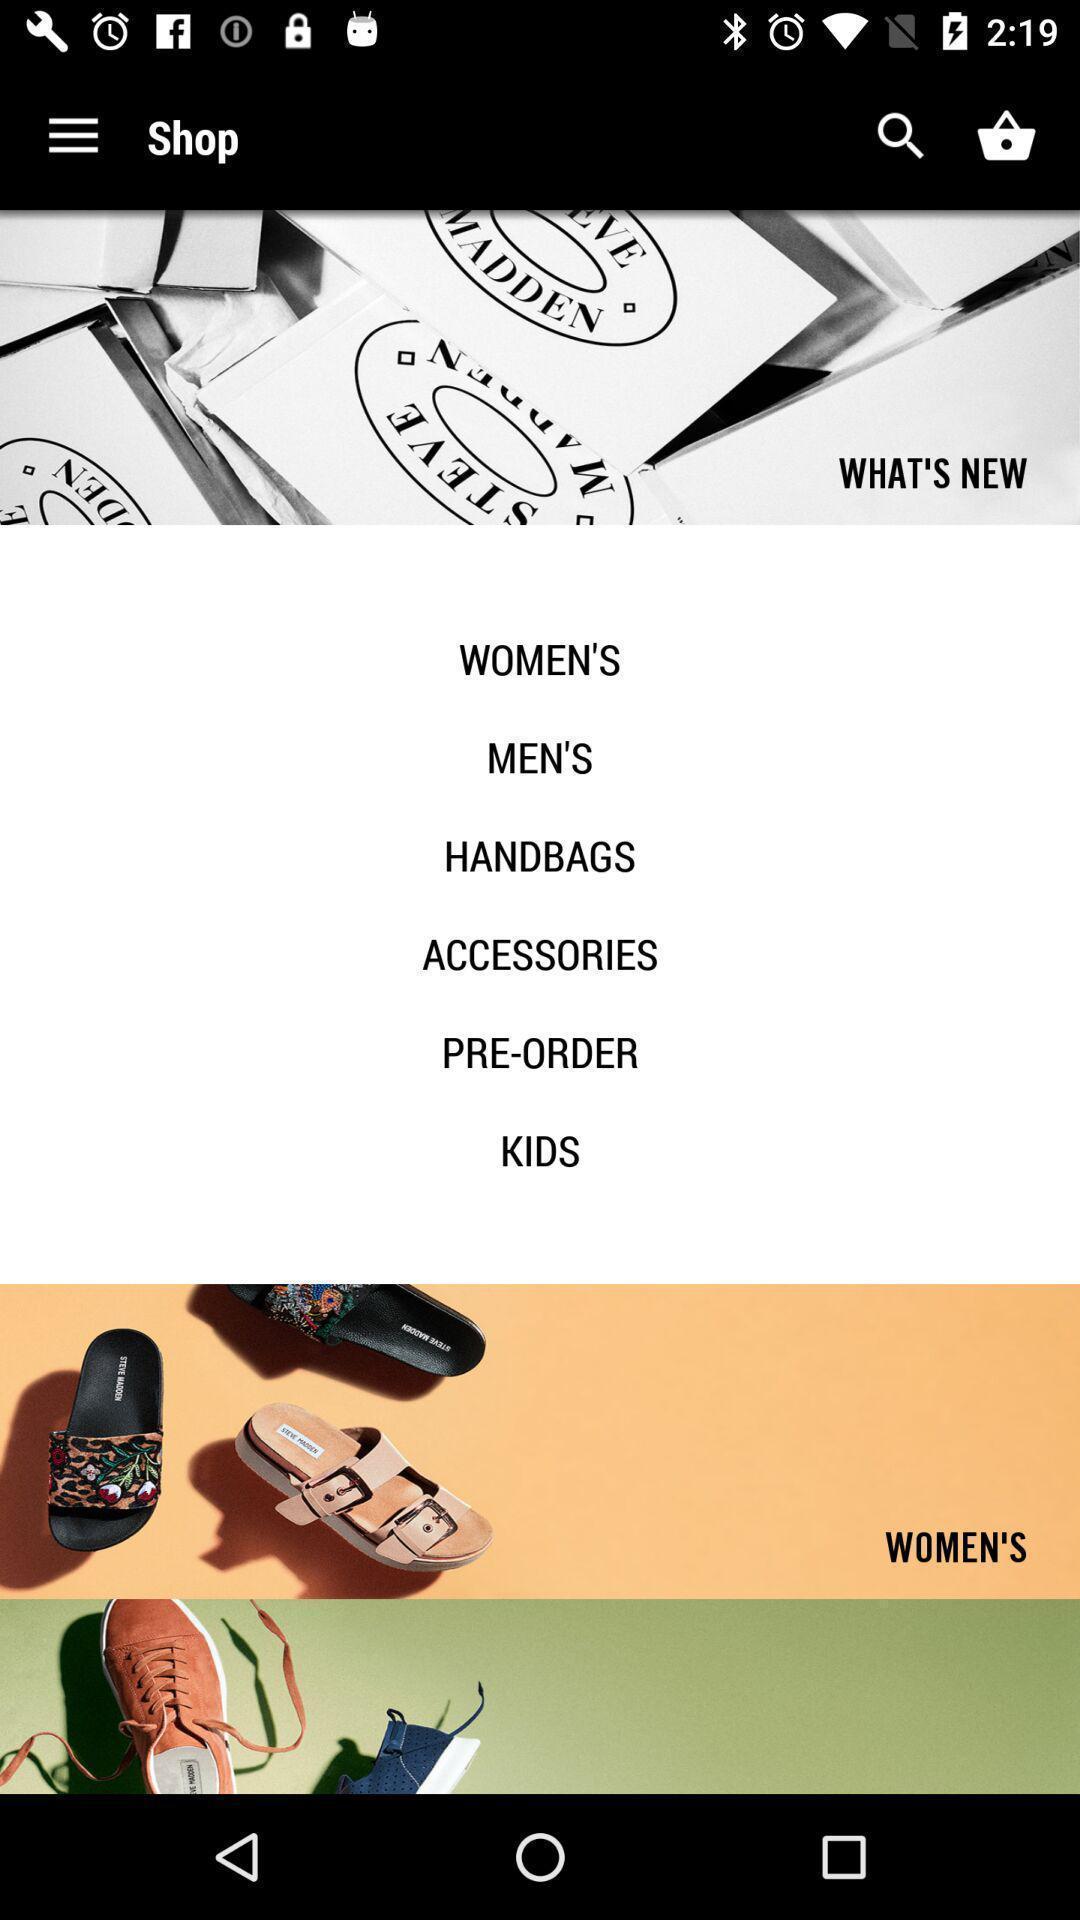Summarize the information in this screenshot. Page showing the home page arel shopping app. 